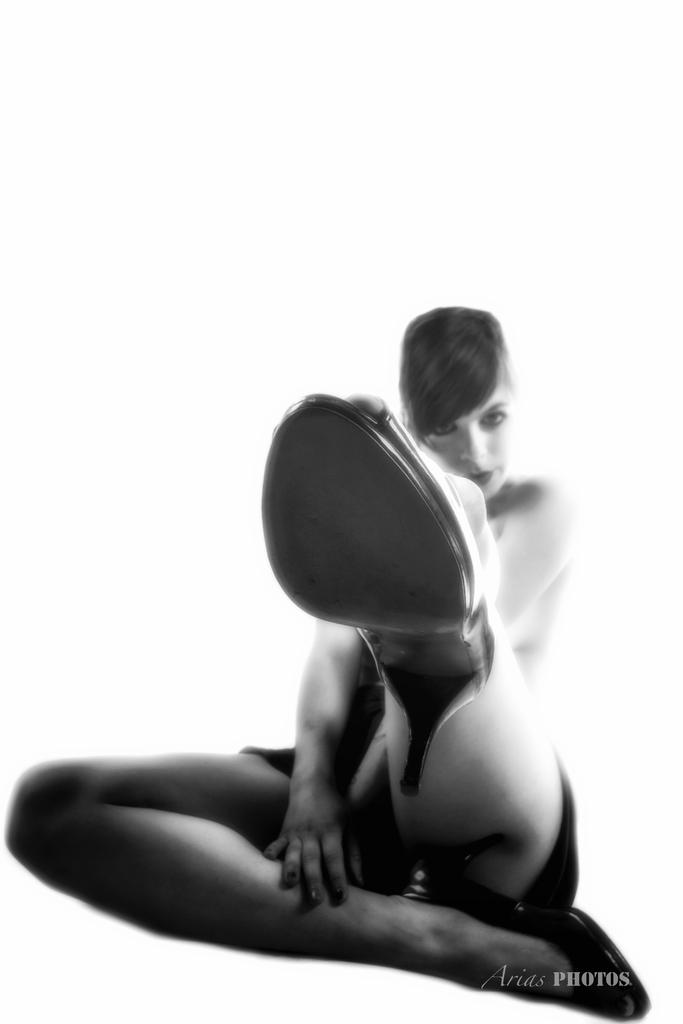What is the color scheme of the image? The image is black and white. What can be seen in the center of the image? There is a lady sitting in the center of the image. What type of footwear is the lady wearing? The lady is wearing heels. What is present at the bottom of the image? There is text at the bottom of the image. How does the lady maintain her balance while holding the potato in the image? There is no potato present in the image, and therefore no such activity can be observed. 